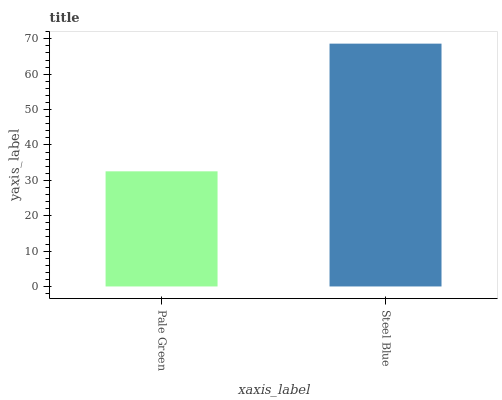Is Pale Green the minimum?
Answer yes or no. Yes. Is Steel Blue the maximum?
Answer yes or no. Yes. Is Steel Blue the minimum?
Answer yes or no. No. Is Steel Blue greater than Pale Green?
Answer yes or no. Yes. Is Pale Green less than Steel Blue?
Answer yes or no. Yes. Is Pale Green greater than Steel Blue?
Answer yes or no. No. Is Steel Blue less than Pale Green?
Answer yes or no. No. Is Steel Blue the high median?
Answer yes or no. Yes. Is Pale Green the low median?
Answer yes or no. Yes. Is Pale Green the high median?
Answer yes or no. No. Is Steel Blue the low median?
Answer yes or no. No. 